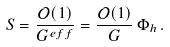<formula> <loc_0><loc_0><loc_500><loc_500>S = \frac { \mathcal { O } ( 1 ) } { G ^ { e f f } } = \frac { \mathcal { O } ( 1 ) } { G } \, \Phi _ { h } \, .</formula> 